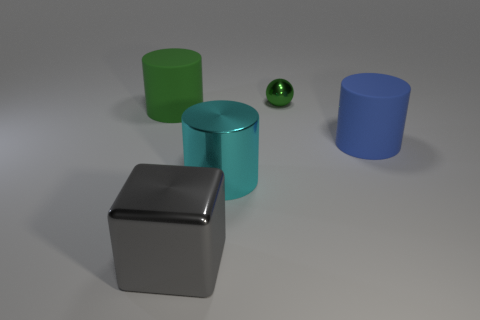Add 5 large cyan cylinders. How many objects exist? 10 Subtract all cylinders. How many objects are left? 2 Subtract all small balls. Subtract all large rubber cylinders. How many objects are left? 2 Add 2 small green metal spheres. How many small green metal spheres are left? 3 Add 5 cubes. How many cubes exist? 6 Subtract 0 purple spheres. How many objects are left? 5 